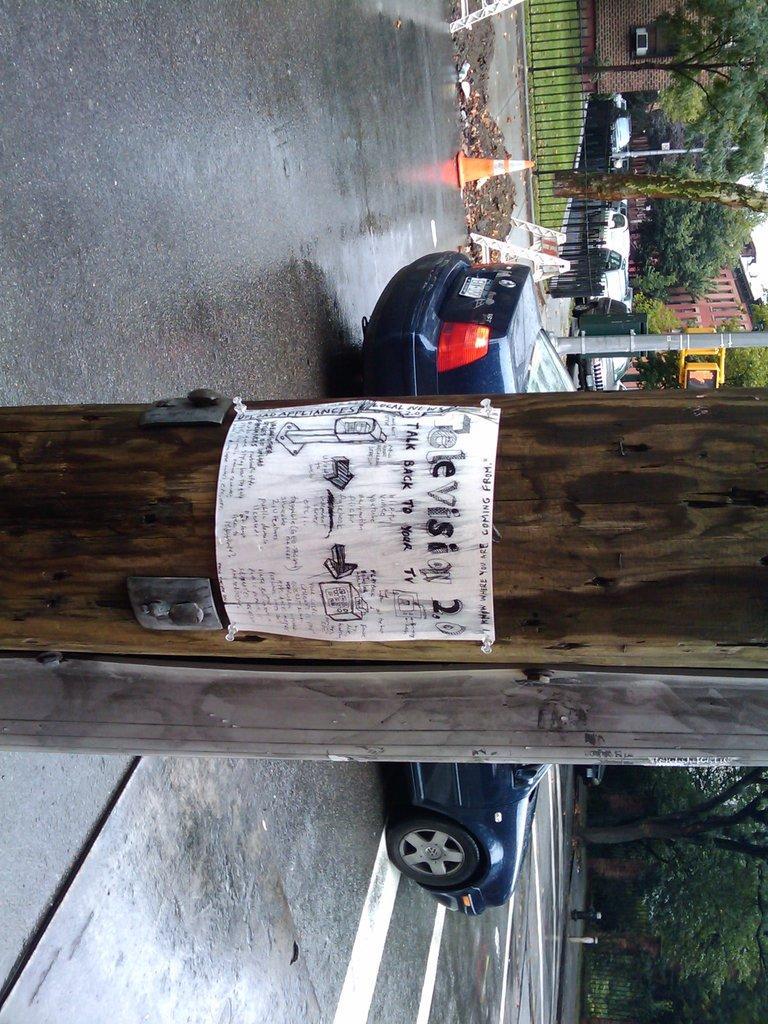Could you give a brief overview of what you see in this image? In the middle it is a tree behind it a car is moving on the road, in the down side there are trees. 